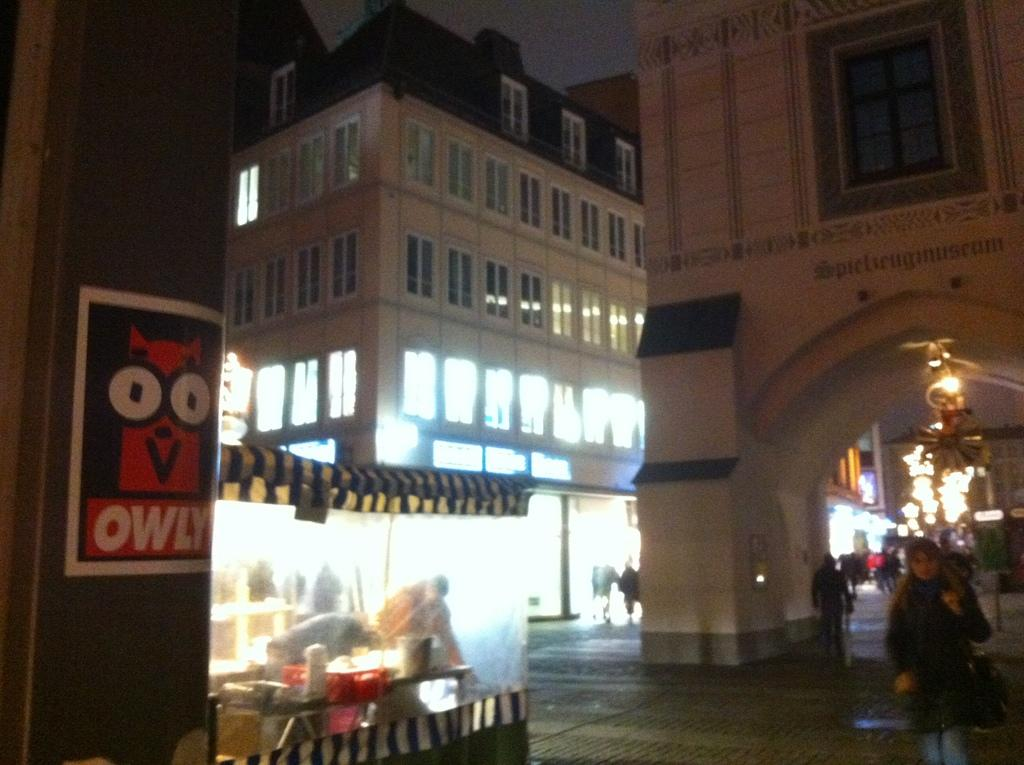What type of structures can be seen in the image? There are buildings in the image. What part of the natural environment is visible in the image? The sky is visible in the image. What is on the pillar in the image? There is an advertisement on a pillar. What type of establishment is present in the image? There is a food stall in the image. What is happening on the road in the image? There are persons on the road in the image. Can you see a rabbit hopping near the food stall in the image? There is no rabbit present in the image. What type of scale is used to weigh the food at the food stall in the image? There is no scale visible at the food stall in the image. 